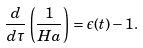<formula> <loc_0><loc_0><loc_500><loc_500>\frac { d } { d \tau } \left ( \frac { 1 } { H a } \right ) = \epsilon ( t ) - 1 .</formula> 